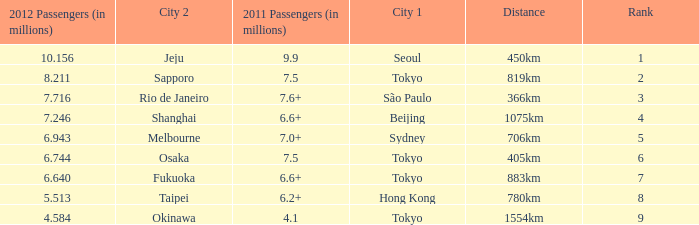How many passengers (in millions) in 2011 flew through along the route that had 6.640 million passengers in 2012? 6.6+. 